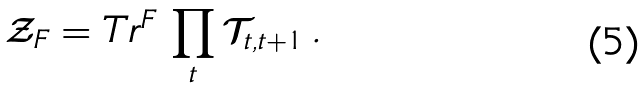Convert formula to latex. <formula><loc_0><loc_0><loc_500><loc_500>\mathcal { Z } _ { F } = T r ^ { F } \, \prod _ { t } \mathcal { T } _ { t , t + 1 } \, .</formula> 